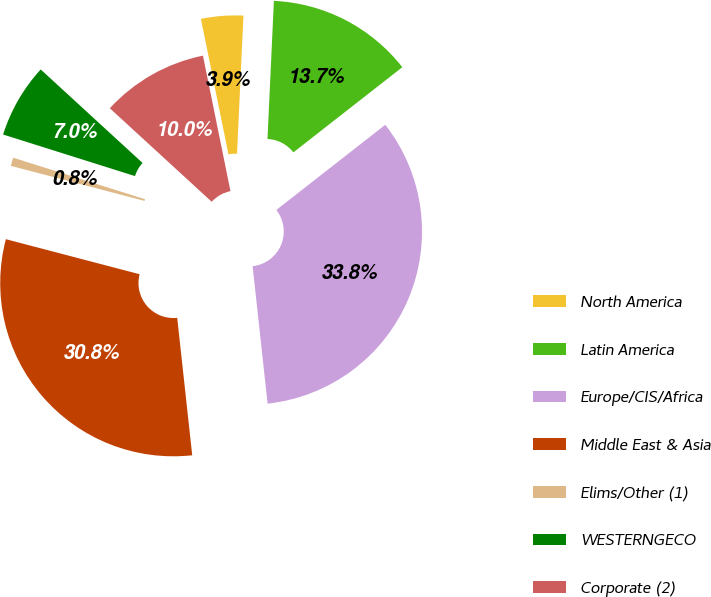Convert chart. <chart><loc_0><loc_0><loc_500><loc_500><pie_chart><fcel>North America<fcel>Latin America<fcel>Europe/CIS/Africa<fcel>Middle East & Asia<fcel>Elims/Other (1)<fcel>WESTERNGECO<fcel>Corporate (2)<nl><fcel>3.93%<fcel>13.7%<fcel>33.83%<fcel>30.81%<fcel>0.78%<fcel>6.96%<fcel>9.99%<nl></chart> 